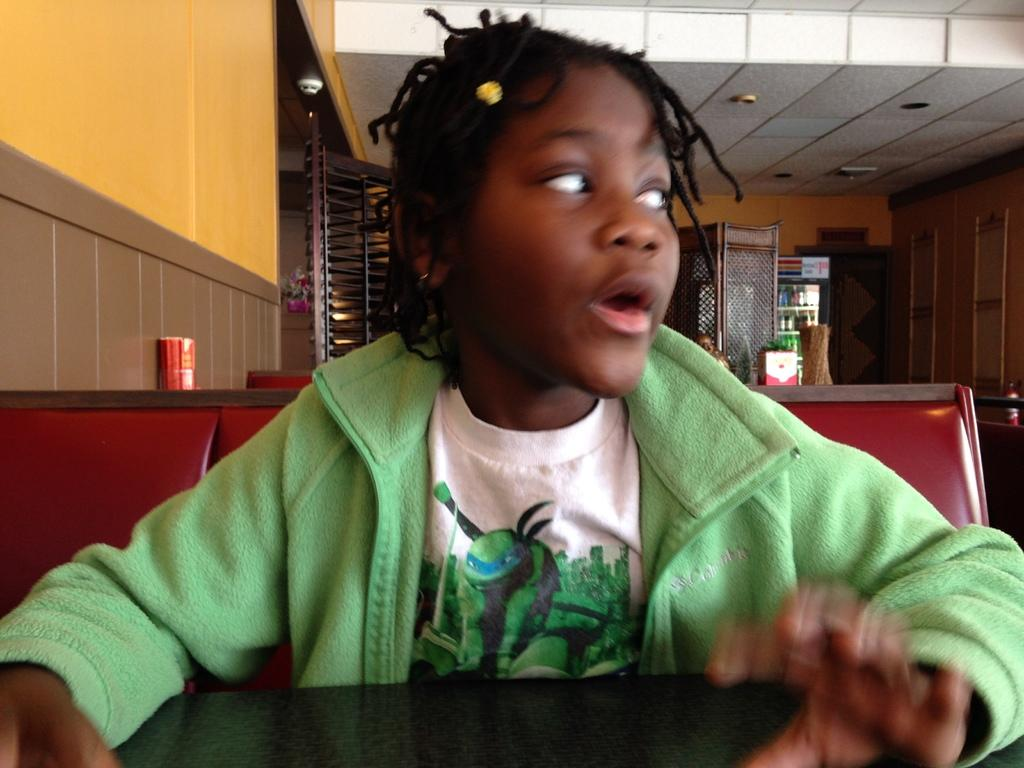What is the main subject of the image? The main subject of the image is a kid. What can be observed about the kid's attire? The kid is wearing clothes. Where is the kid positioned in the image? The kid is sitting in front of a table. What is visible at the top of the image? There is a ceiling visible at the top of the image. What is the price of the truck in the image? There is no truck present in the image, so it is not possible to determine its price. 